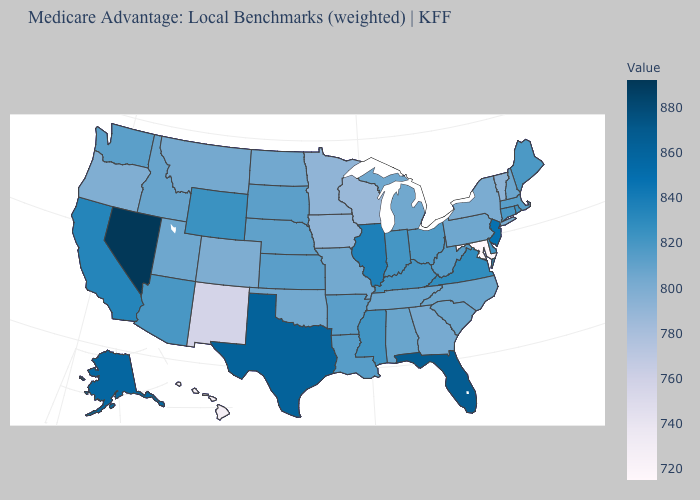Which states have the lowest value in the MidWest?
Be succinct. Wisconsin. Does Nevada have the highest value in the USA?
Quick response, please. Yes. Which states have the lowest value in the Northeast?
Be succinct. Vermont. Does Nebraska have the lowest value in the USA?
Quick response, please. No. 